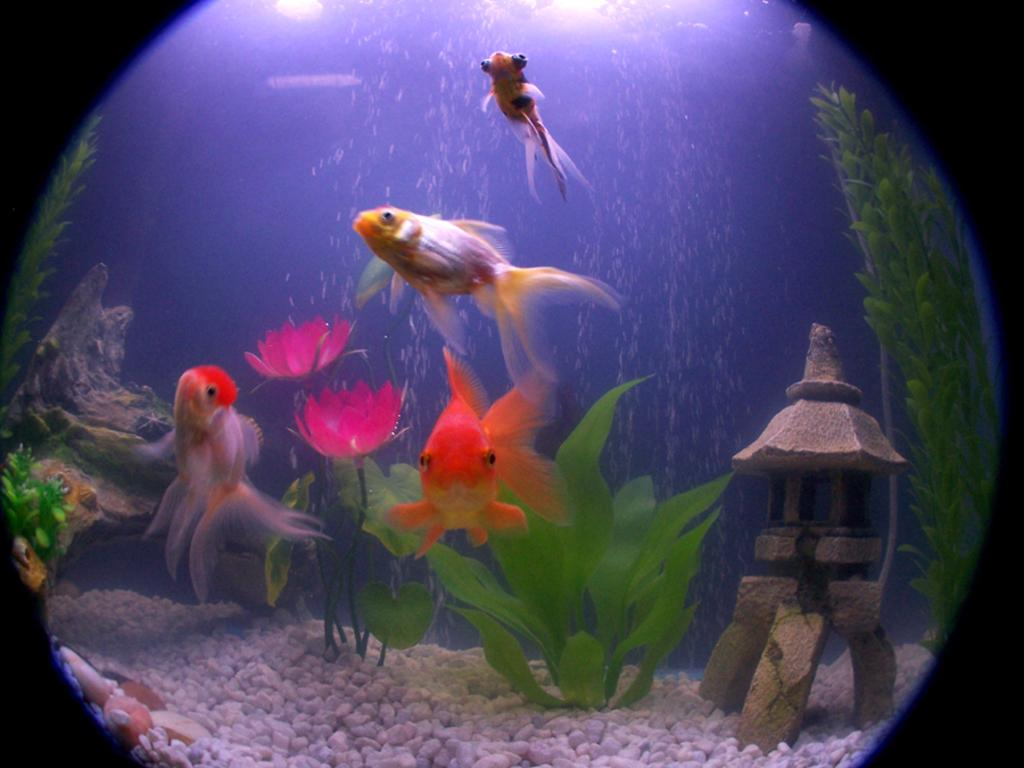What type of animals can be seen in the water in the image? There are fishes in the water in the image. What other elements can be seen in the image besides the water? There are flowers, plants, a small wooden log, and small stones visible in the image. What is the source of illumination at the top of the image? There are lights visible at the top of the image. What is the shape of the image? The image is in a spherical shape. What type of songs can be heard coming from the bridge in the image? There is no bridge present in the image, so it's not possible to determine what, if any, songs might be heard. What is the engine used for in the image? There is no engine present in the image. 